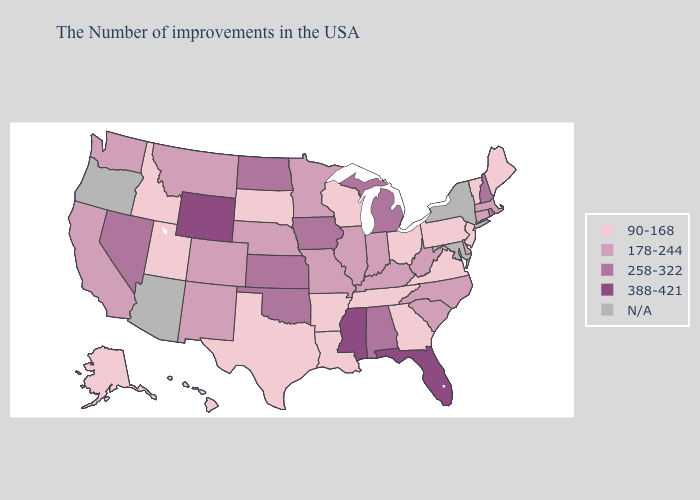What is the highest value in the MidWest ?
Write a very short answer. 258-322. What is the lowest value in the USA?
Give a very brief answer. 90-168. Does Oklahoma have the lowest value in the USA?
Short answer required. No. What is the value of Wisconsin?
Quick response, please. 90-168. Is the legend a continuous bar?
Be succinct. No. Is the legend a continuous bar?
Quick response, please. No. Is the legend a continuous bar?
Answer briefly. No. Among the states that border Wyoming , does Utah have the lowest value?
Quick response, please. Yes. What is the value of Connecticut?
Concise answer only. 178-244. What is the value of Minnesota?
Answer briefly. 178-244. Among the states that border Texas , which have the highest value?
Be succinct. Oklahoma. Does Connecticut have the highest value in the Northeast?
Answer briefly. No. What is the lowest value in the West?
Write a very short answer. 90-168. 